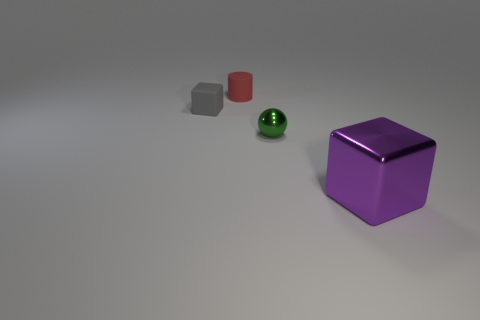Add 3 purple things. How many objects exist? 7 Subtract all cylinders. How many objects are left? 3 Add 1 tiny cylinders. How many tiny cylinders are left? 2 Add 3 large green rubber objects. How many large green rubber objects exist? 3 Subtract 0 red cubes. How many objects are left? 4 Subtract all small metallic things. Subtract all big brown spheres. How many objects are left? 3 